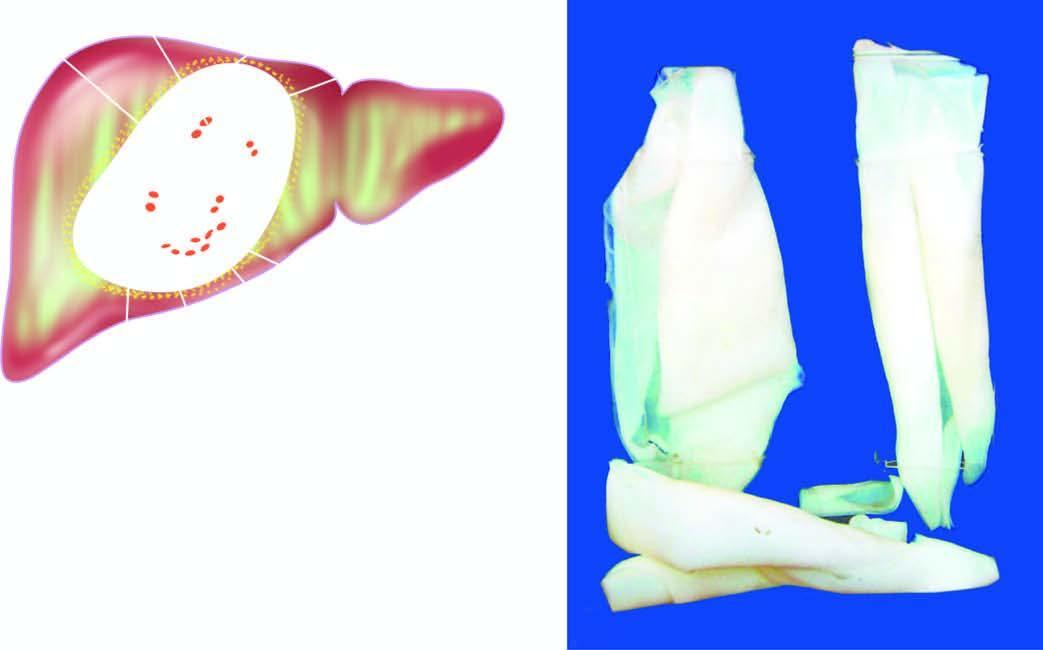s the cyst wall composed of whitish membrane resembling the membrane of a hard boiled egg?
Answer the question using a single word or phrase. Yes 